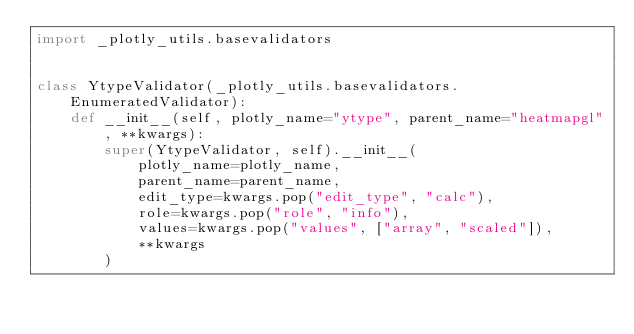Convert code to text. <code><loc_0><loc_0><loc_500><loc_500><_Python_>import _plotly_utils.basevalidators


class YtypeValidator(_plotly_utils.basevalidators.EnumeratedValidator):
    def __init__(self, plotly_name="ytype", parent_name="heatmapgl", **kwargs):
        super(YtypeValidator, self).__init__(
            plotly_name=plotly_name,
            parent_name=parent_name,
            edit_type=kwargs.pop("edit_type", "calc"),
            role=kwargs.pop("role", "info"),
            values=kwargs.pop("values", ["array", "scaled"]),
            **kwargs
        )
</code> 